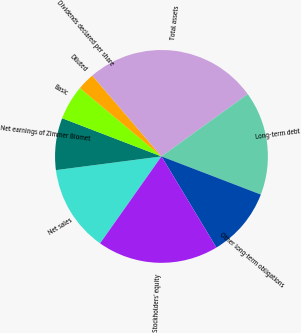Convert chart to OTSL. <chart><loc_0><loc_0><loc_500><loc_500><pie_chart><fcel>Net sales<fcel>Net earnings of Zimmer Biomet<fcel>Basic<fcel>Diluted<fcel>Dividends declared per share<fcel>Total assets<fcel>Long-term debt<fcel>Other long-term obligations<fcel>Stockholders' equity<nl><fcel>13.16%<fcel>7.9%<fcel>5.26%<fcel>2.63%<fcel>0.0%<fcel>26.31%<fcel>15.79%<fcel>10.53%<fcel>18.42%<nl></chart> 